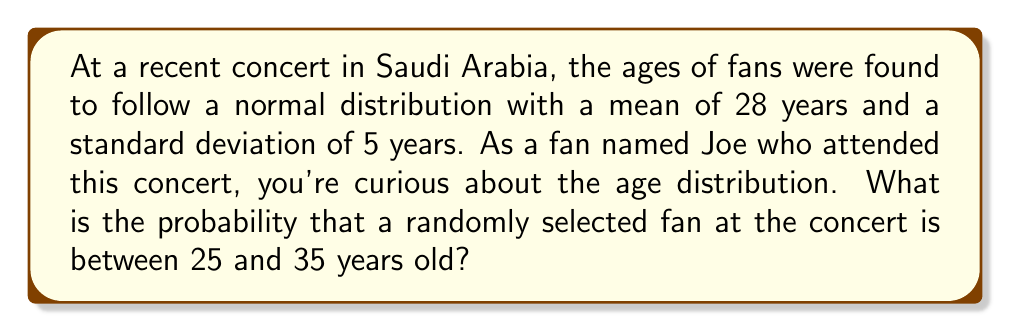Provide a solution to this math problem. Let's approach this step-by-step:

1) We're dealing with a normal distribution where:
   $\mu = 28$ (mean age)
   $\sigma = 5$ (standard deviation of ages)

2) We want to find $P(25 \leq X \leq 35)$, where $X$ is the age of a randomly selected fan.

3) To use the standard normal distribution, we need to standardize these values:
   For 25: $z_1 = \frac{25 - 28}{5} = -0.6$
   For 35: $z_2 = \frac{35 - 28}{5} = 1.4$

4) Now we're looking for $P(-0.6 \leq Z \leq 1.4)$, where $Z$ is the standard normal variable.

5) We can find this probability using the standard normal table or a calculator:
   $P(-0.6 \leq Z \leq 1.4) = P(Z \leq 1.4) - P(Z \leq -0.6)$

6) Using a standard normal table or calculator:
   $P(Z \leq 1.4) \approx 0.9192$
   $P(Z \leq -0.6) \approx 0.2743$

7) Therefore:
   $P(-0.6 \leq Z \leq 1.4) = 0.9192 - 0.2743 \approx 0.6449$

8) Convert to a percentage: $0.6449 \times 100\% = 64.49\%$

Thus, there is approximately a 64.49% chance that a randomly selected fan at the concert is between 25 and 35 years old.
Answer: 64.49% 